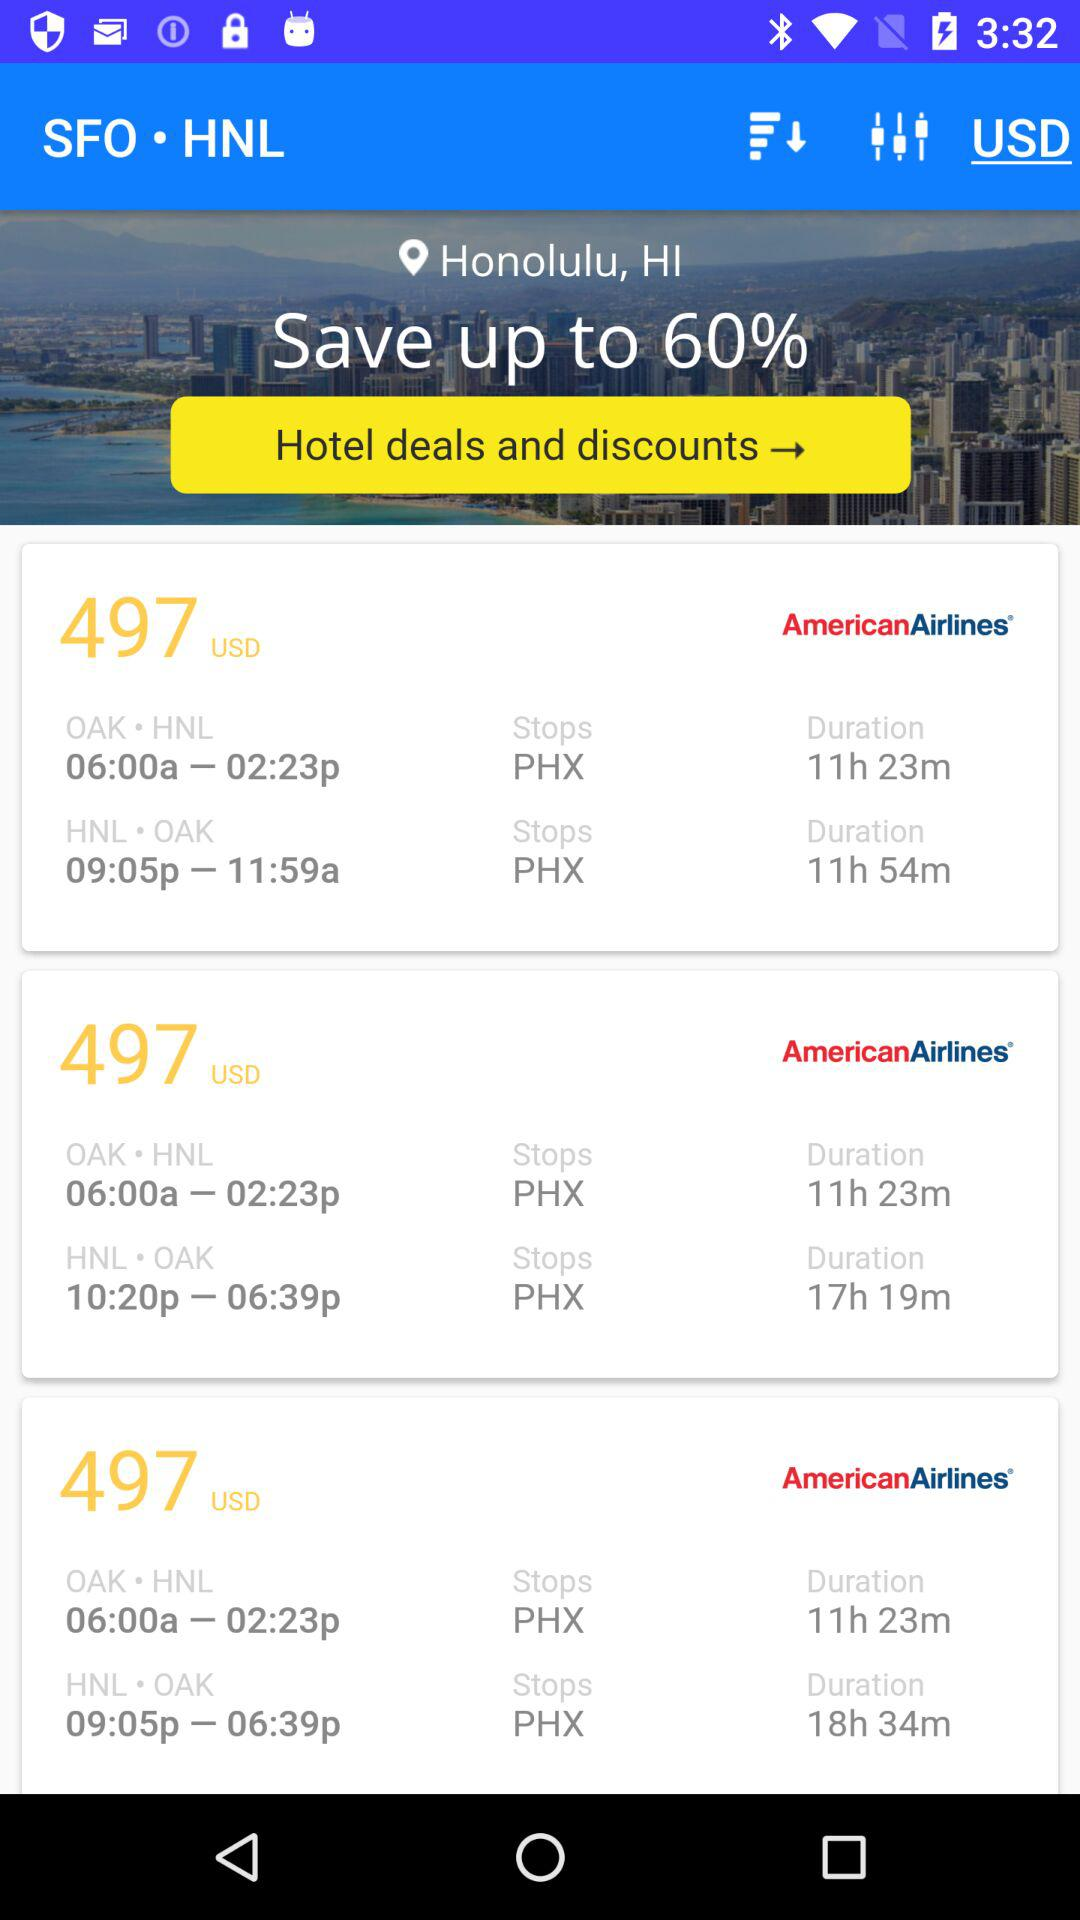What's the round-trip cost from Oakland to Honolulu via "American Airlines"? The round-trip cost from Oakland to Honolulu via "American Airlines" is 497 USD. 